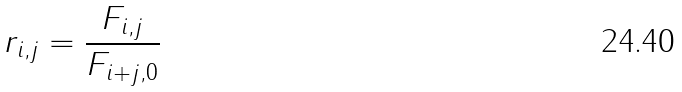Convert formula to latex. <formula><loc_0><loc_0><loc_500><loc_500>r _ { i , j } = \frac { F _ { i , j } } { F _ { i + j , 0 } }</formula> 